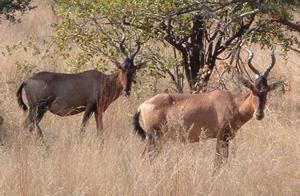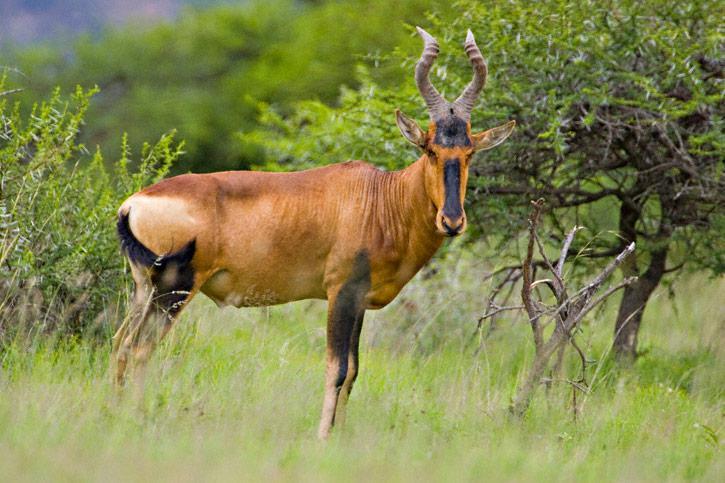The first image is the image on the left, the second image is the image on the right. Analyze the images presented: Is the assertion "Lefthand image contains two horned animals standing in a field." valid? Answer yes or no. Yes. The first image is the image on the left, the second image is the image on the right. Given the left and right images, does the statement "One of the images shows exactly two antelopes that are standing." hold true? Answer yes or no. Yes. 